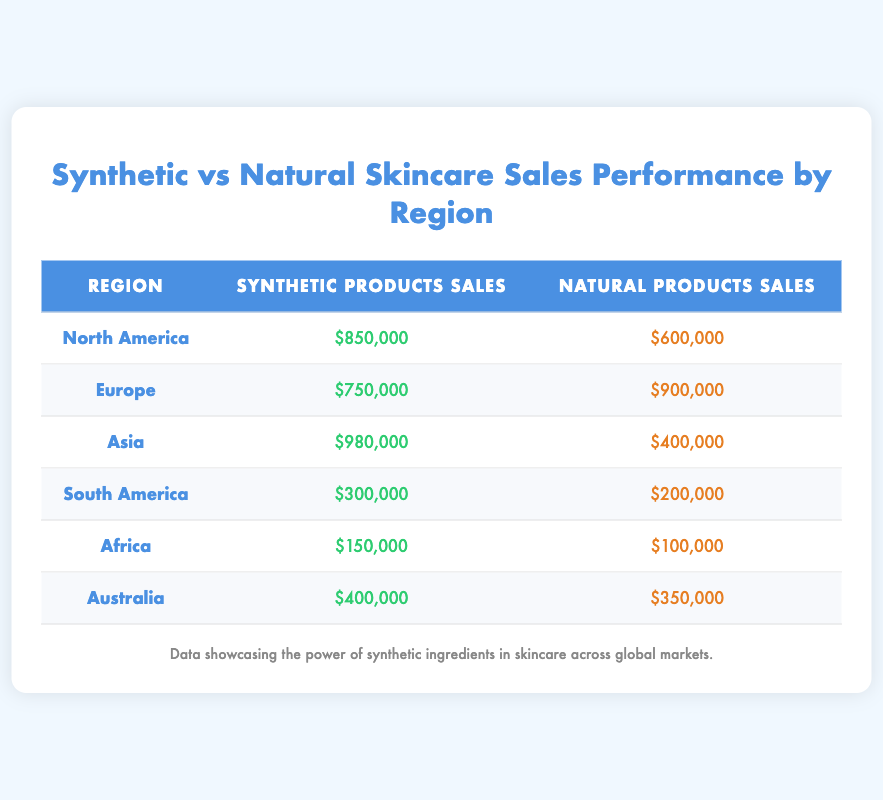What is the total sales for synthetic products in North America? From the table, the synthetic products sales in North America are listed as $850,000.
Answer: $850,000 Which region has the highest sales for natural products? By examining the table, Europe has the highest natural products sales at $900,000 compared to other regions.
Answer: Europe What is the difference in sales between synthetic and natural products in Asia? In Asia, synthetic products sales are $980,000 and natural products sales are $400,000. The difference is $980,000 - $400,000 = $580,000.
Answer: $580,000 Is it true that South America has higher natural product sales than synthetic product sales? Looking at the table, South America has natural product sales of $200,000 and synthetic product sales of $300,000, showing that synthetic product sales are higher. Therefore, it's false.
Answer: False What is the average sales of synthetic products across all regions? To find the average, sum the synthetic products sales: $850,000 (North America) + $750,000 (Europe) + $980,000 (Asia) + $300,000 (South America) + $150,000 (Africa) + $400,000 (Australia) = $2,630,000. There are 6 regions, so the average is $2,630,000 / 6 = $438,333.33.
Answer: $438,333.33 Which region shows the lowest sales for synthetic products? According to the table, Africa has the lowest sales for synthetic products at $150,000 compared to other regions.
Answer: Africa What are the total sales for all natural products combined? To find the total, sum the natural products sales: $600,000 (North America) + $900,000 (Europe) + $400,000 (Asia) + $200,000 (South America) + $100,000 (Africa) + $350,000 (Australia) = $2,550,000.
Answer: $2,550,000 Is it correct that Australia has higher sales for synthetic products than South America? From the table, Australia has synthetic products sales of $400,000 and South America has $300,000, confirming the statement is true.
Answer: True 